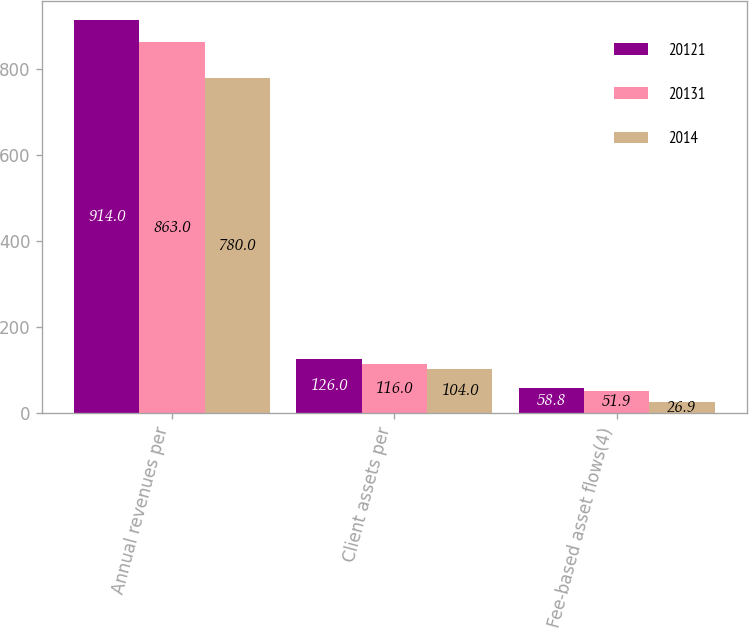Convert chart to OTSL. <chart><loc_0><loc_0><loc_500><loc_500><stacked_bar_chart><ecel><fcel>Annual revenues per<fcel>Client assets per<fcel>Fee-based asset flows(4)<nl><fcel>20121<fcel>914<fcel>126<fcel>58.8<nl><fcel>20131<fcel>863<fcel>116<fcel>51.9<nl><fcel>2014<fcel>780<fcel>104<fcel>26.9<nl></chart> 